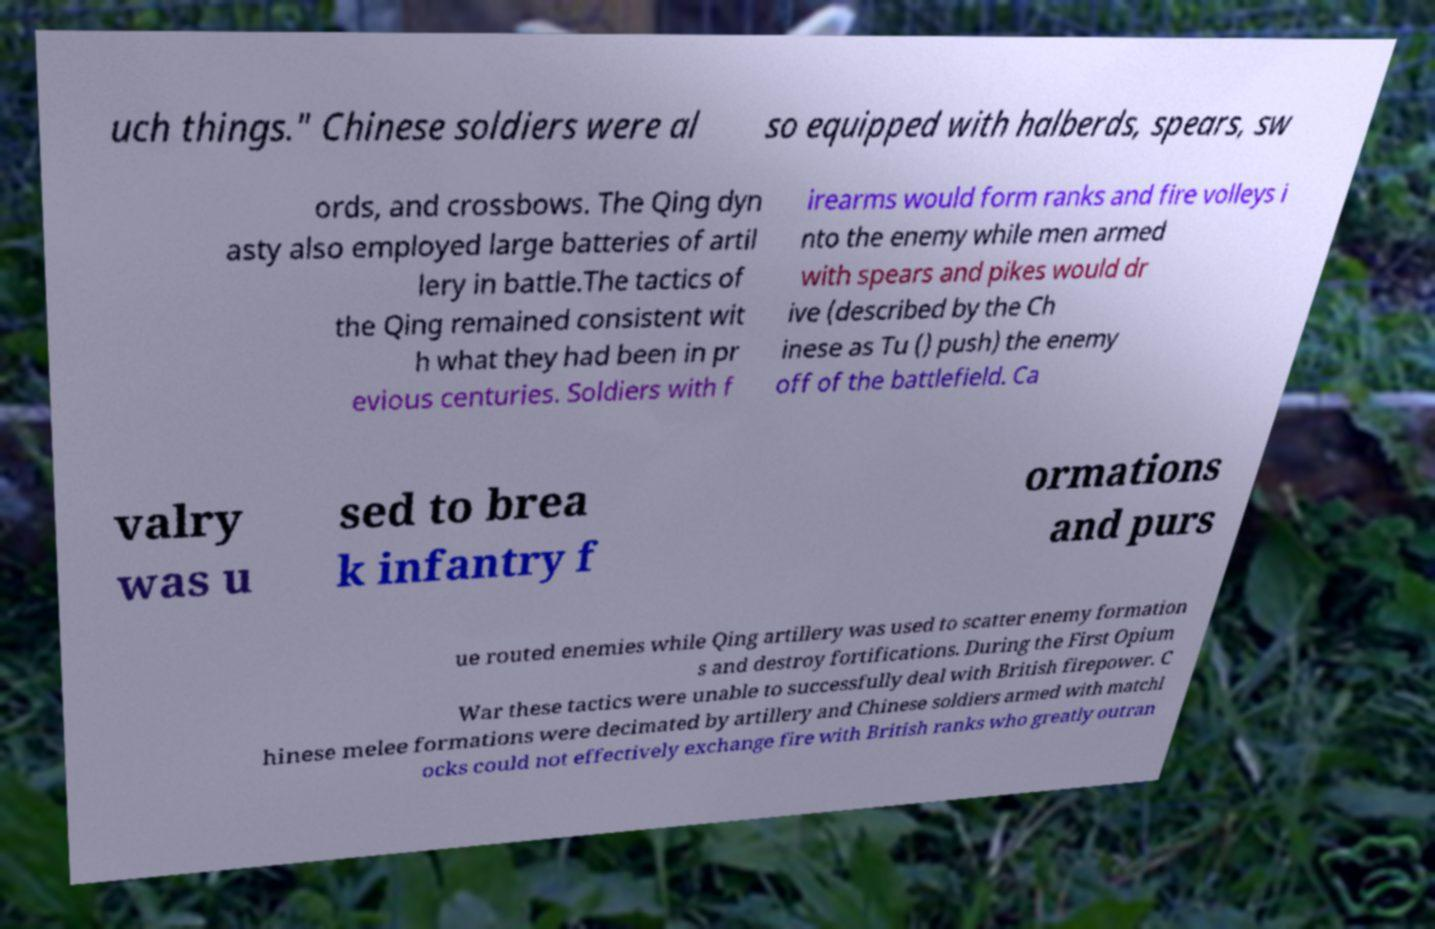Could you assist in decoding the text presented in this image and type it out clearly? uch things." Chinese soldiers were al so equipped with halberds, spears, sw ords, and crossbows. The Qing dyn asty also employed large batteries of artil lery in battle.The tactics of the Qing remained consistent wit h what they had been in pr evious centuries. Soldiers with f irearms would form ranks and fire volleys i nto the enemy while men armed with spears and pikes would dr ive (described by the Ch inese as Tu () push) the enemy off of the battlefield. Ca valry was u sed to brea k infantry f ormations and purs ue routed enemies while Qing artillery was used to scatter enemy formation s and destroy fortifications. During the First Opium War these tactics were unable to successfully deal with British firepower. C hinese melee formations were decimated by artillery and Chinese soldiers armed with matchl ocks could not effectively exchange fire with British ranks who greatly outran 